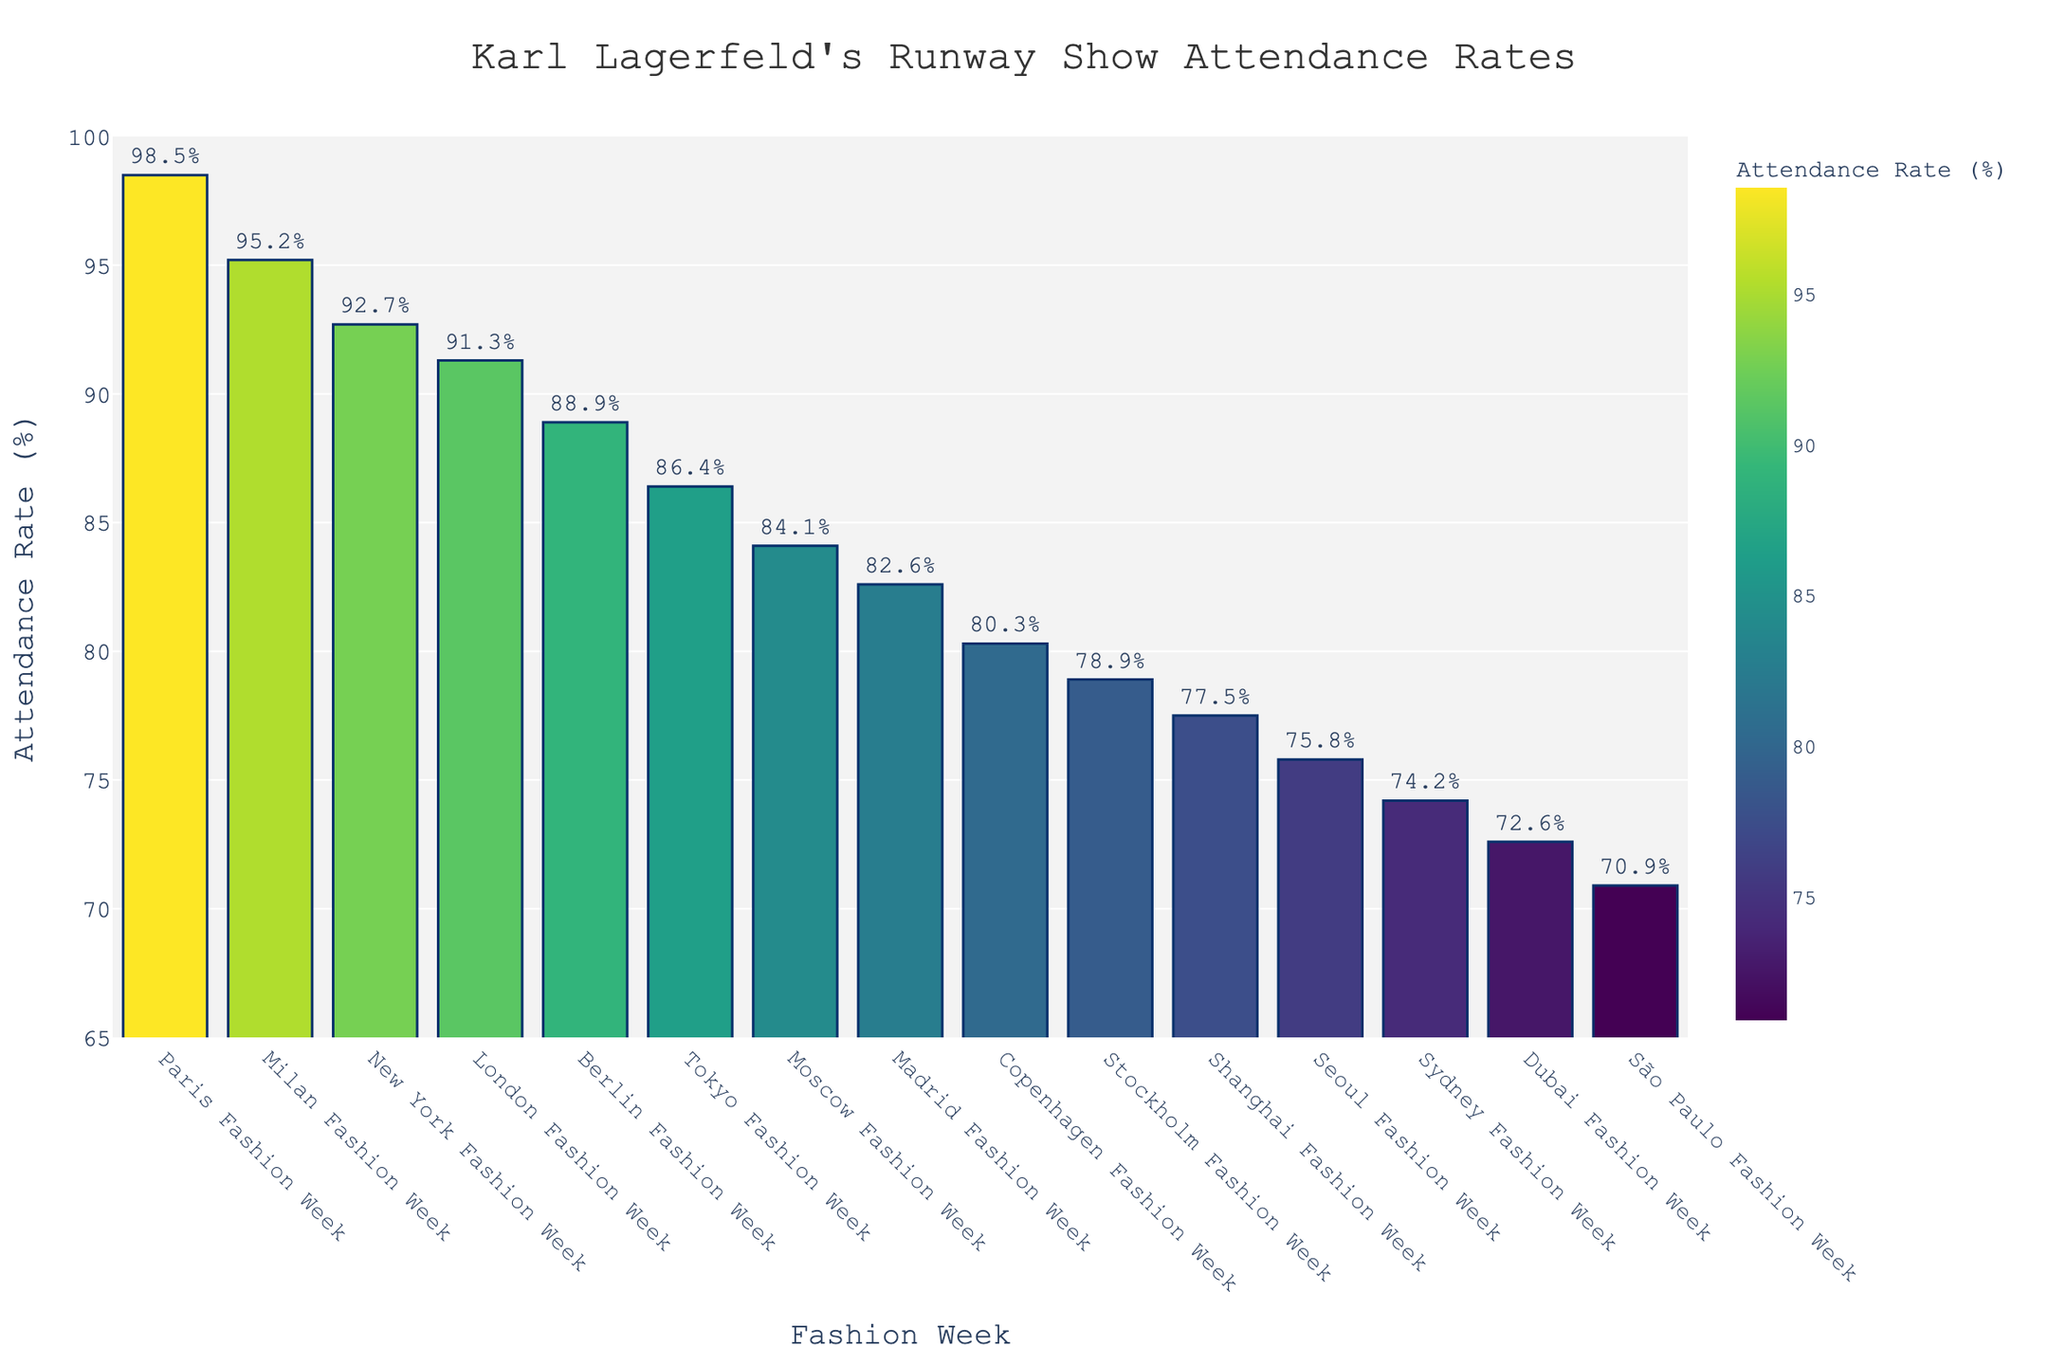What is the attendance rate difference between Paris Fashion Week and Dubai Fashion Week? From the bar chart, find the attendance rates for Paris Fashion Week (98.5%) and Dubai Fashion Week (72.6%). Calculate the difference as 98.5 - 72.6.
Answer: 25.9% Which Fashion Week has the lowest attendance rate? Identify the bar with the smallest height; it's São Paulo Fashion Week, with an attendance rate of 70.9%.
Answer: São Paulo Fashion Week What is the sum of the attendance rates for Tokyo Fashion Week and Seoul Fashion Week? Find the attendance rates for Tokyo (86.4%) and Seoul (75.8%) from the bar chart. Add these rates together, 86.4 + 75.8.
Answer: 162.2% Between New York Fashion Week and Milan Fashion Week, which has a higher attendance rate and by how much? Look at the bar heights for New York (92.7%) and Milan (95.2%). Subtract the lower value from the higher value, 95.2 - 92.7.
Answer: Milan by 2.5% What is the average attendance rate of the top three Fashion Weeks in the chart? The top three Fashion Weeks in terms of attendance are Paris (98.5%), Milan (95.2%), and New York (92.7%). Calculate the average: (98.5 + 95.2 + 92.7) / 3.
Answer: 95.47% How many Fashion Weeks have an attendance rate above 90%? Count the number of bars with heights indicating attendance rates above 90%. These include Paris, Milan, New York, and London.
Answer: 4 What is the attendance rate range for the Fashion Weeks shown in the chart? Find the highest (Paris, 98.5%) and lowest (São Paulo, 70.9%) attendance rates. Calculate the range: 98.5 - 70.9.
Answer: 27.6% Which Fashion Weeks have an attendance rate between 80% and 85%? Identify bars whose height represents attendance rates within the 80%-85% range. These are Copenhagen, Stockholm, Shanghai, and Moscow.
Answer: Copenhagen, Stockholm, Shanghai, Moscow Is the sum of attendance rates for the bottom two Fashion Weeks greater than 145%? The bottom two Fashion Weeks are São Paulo (70.9%) and Dubai (72.6%). Sum their rates: 70.9 + 72.6 = 143.5, which is not greater than 145%.
Answer: No What is the difference in attendance rates between the most attended Fashion Week and the least attended Fashion Week in Europe? The most attended Fashion Week in Europe is Paris (98.5%), and the least attended in Europe is Stockholm (78.9%). Calculate the difference: 98.5 - 78.9.
Answer: 19.6% 